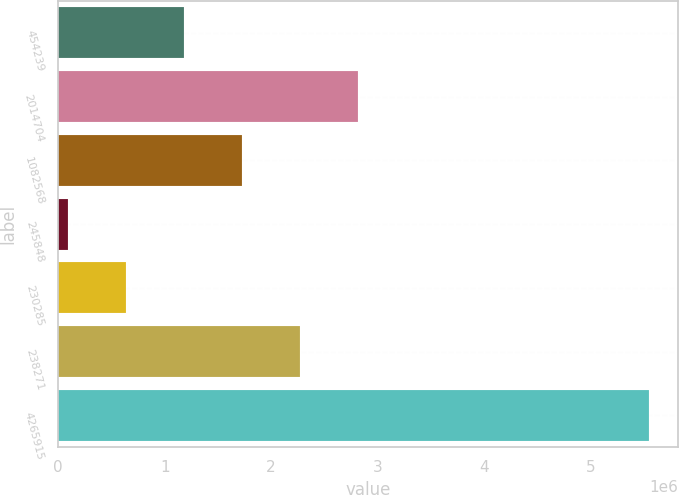Convert chart. <chart><loc_0><loc_0><loc_500><loc_500><bar_chart><fcel>454239<fcel>2014704<fcel>1082568<fcel>245848<fcel>230285<fcel>238271<fcel>4265915<nl><fcel>1.18266e+06<fcel>2.82001e+06<fcel>1.72845e+06<fcel>91094<fcel>636878<fcel>2.27423e+06<fcel>5.54893e+06<nl></chart> 